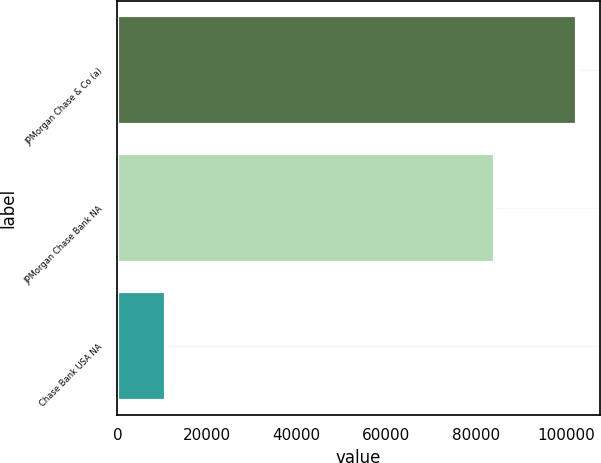<chart> <loc_0><loc_0><loc_500><loc_500><bar_chart><fcel>JPMorgan Chase & Co (a)<fcel>JPMorgan Chase Bank NA<fcel>Chase Bank USA NA<nl><fcel>102437<fcel>84227<fcel>10941<nl></chart> 